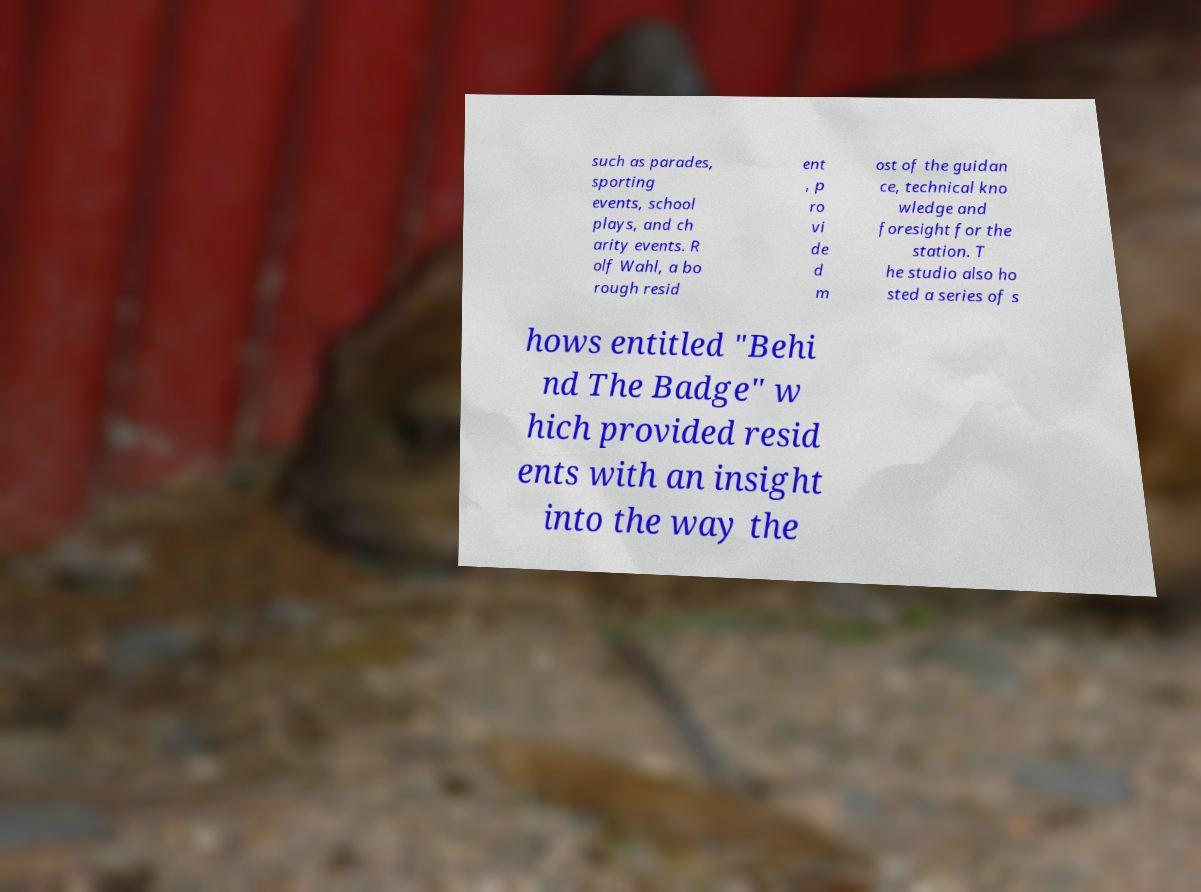Can you accurately transcribe the text from the provided image for me? such as parades, sporting events, school plays, and ch arity events. R olf Wahl, a bo rough resid ent , p ro vi de d m ost of the guidan ce, technical kno wledge and foresight for the station. T he studio also ho sted a series of s hows entitled "Behi nd The Badge" w hich provided resid ents with an insight into the way the 